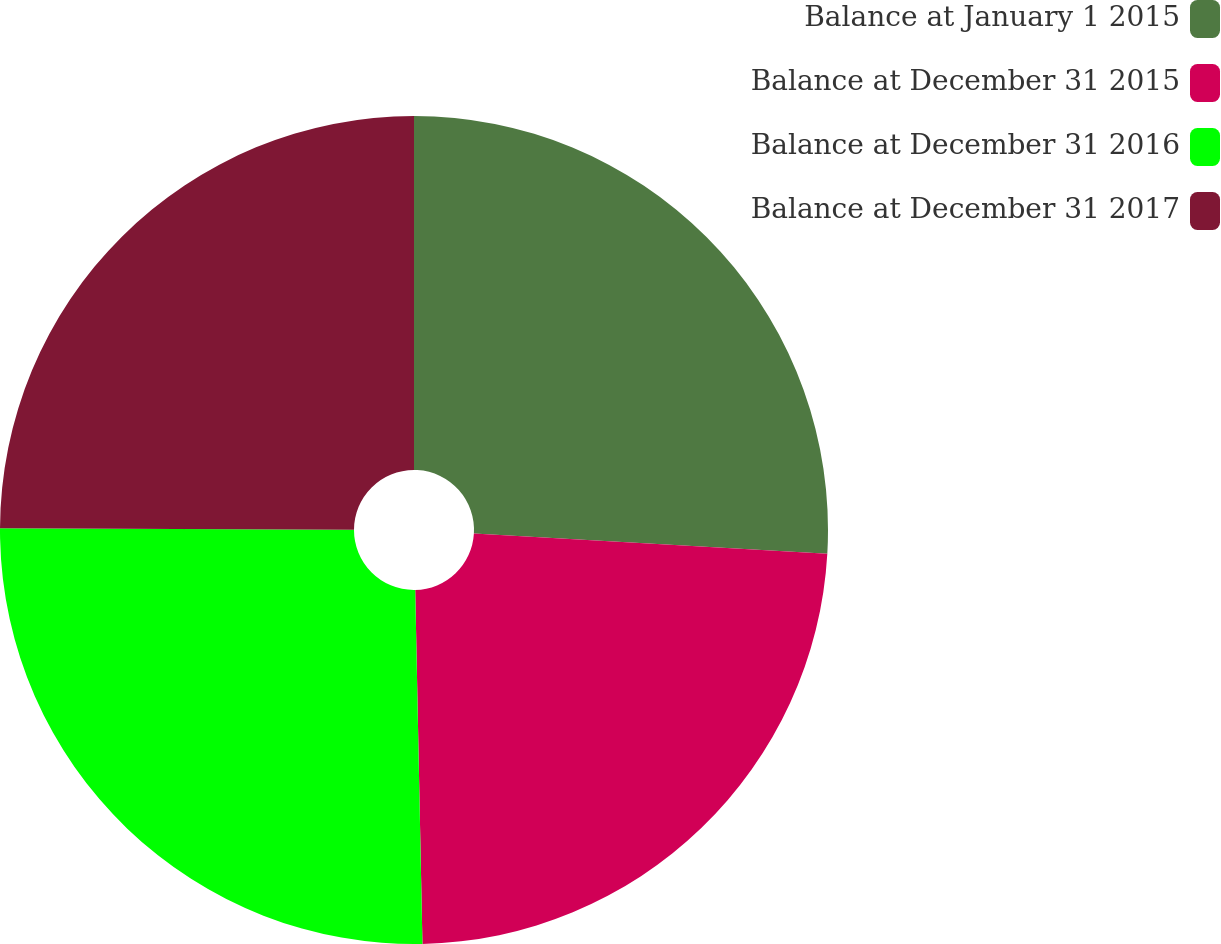Convert chart to OTSL. <chart><loc_0><loc_0><loc_500><loc_500><pie_chart><fcel>Balance at January 1 2015<fcel>Balance at December 31 2015<fcel>Balance at December 31 2016<fcel>Balance at December 31 2017<nl><fcel>25.91%<fcel>23.76%<fcel>25.39%<fcel>24.93%<nl></chart> 